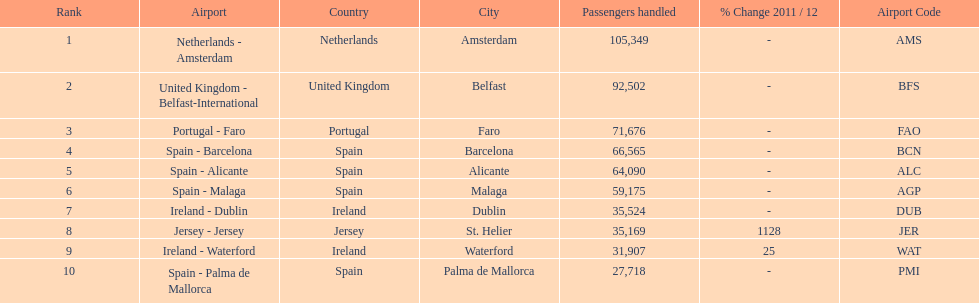What are all of the destinations out of the london southend airport? Netherlands - Amsterdam, United Kingdom - Belfast-International, Portugal - Faro, Spain - Barcelona, Spain - Alicante, Spain - Malaga, Ireland - Dublin, Jersey - Jersey, Ireland - Waterford, Spain - Palma de Mallorca. How many passengers has each destination handled? 105,349, 92,502, 71,676, 66,565, 64,090, 59,175, 35,524, 35,169, 31,907, 27,718. And of those, which airport handled the fewest passengers? Spain - Palma de Mallorca. Can you give me this table as a dict? {'header': ['Rank', 'Airport', 'Country', 'City', 'Passengers handled', '% Change 2011 / 12', 'Airport Code'], 'rows': [['1', 'Netherlands - Amsterdam', 'Netherlands', 'Amsterdam', '105,349', '-', 'AMS'], ['2', 'United Kingdom - Belfast-International', 'United Kingdom', 'Belfast', '92,502', '-', 'BFS'], ['3', 'Portugal - Faro', 'Portugal', 'Faro', '71,676', '-', 'FAO'], ['4', 'Spain - Barcelona', 'Spain', 'Barcelona', '66,565', '-', 'BCN'], ['5', 'Spain - Alicante', 'Spain', 'Alicante', '64,090', '-', 'ALC'], ['6', 'Spain - Malaga', 'Spain', 'Malaga', '59,175', '-', 'AGP'], ['7', 'Ireland - Dublin', 'Ireland', 'Dublin', '35,524', '-', 'DUB'], ['8', 'Jersey - Jersey', 'Jersey', 'St. Helier', '35,169', '1128', 'JER'], ['9', 'Ireland - Waterford', 'Ireland', 'Waterford', '31,907', '25', 'WAT'], ['10', 'Spain - Palma de Mallorca', 'Spain', 'Palma de Mallorca', '27,718', '-', 'PMI']]} 